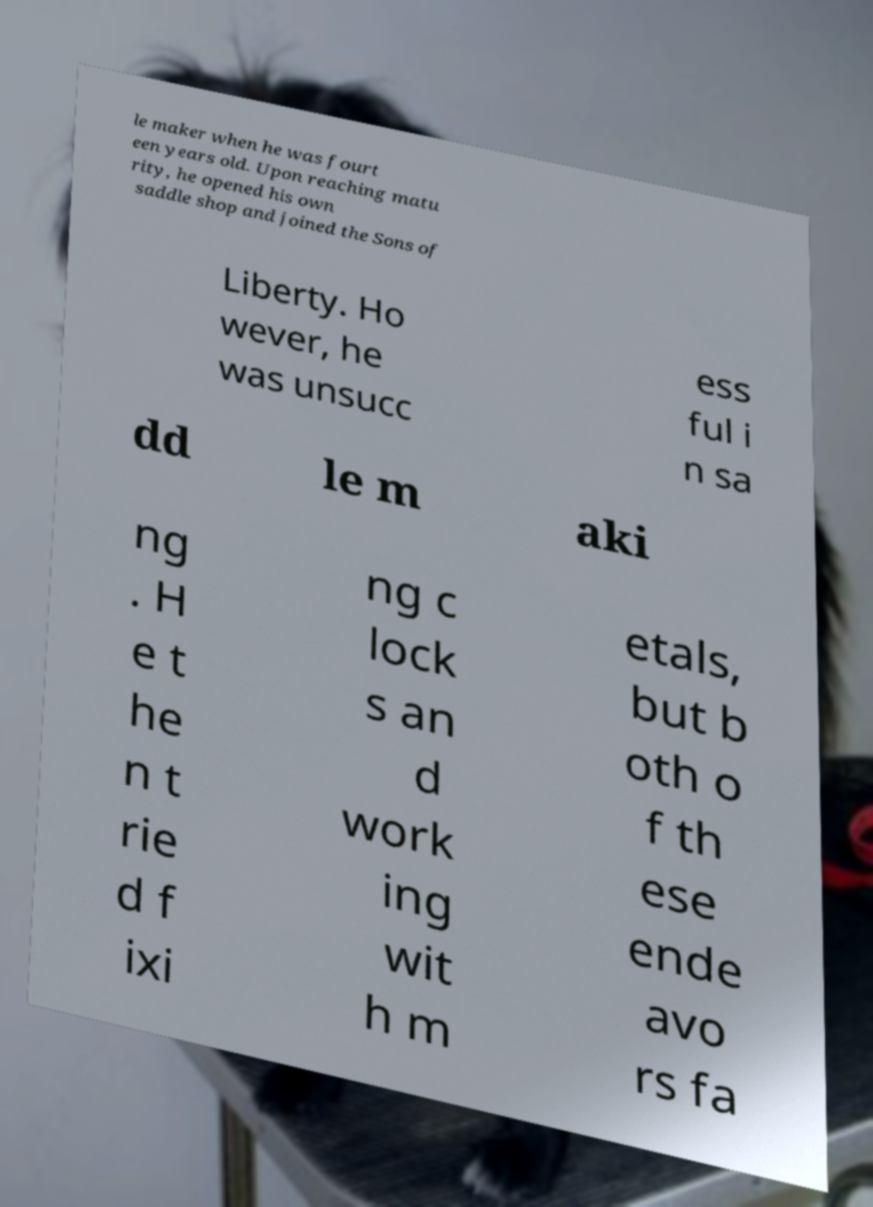Could you extract and type out the text from this image? le maker when he was fourt een years old. Upon reaching matu rity, he opened his own saddle shop and joined the Sons of Liberty. Ho wever, he was unsucc ess ful i n sa dd le m aki ng . H e t he n t rie d f ixi ng c lock s an d work ing wit h m etals, but b oth o f th ese ende avo rs fa 